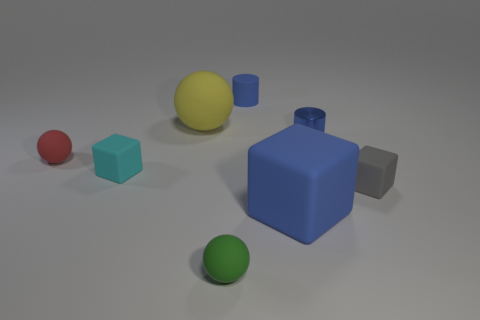What is the big yellow ball made of?
Keep it short and to the point. Rubber. What size is the matte object that is right of the blue matte cylinder and in front of the small gray thing?
Your response must be concise. Large. There is a large block that is the same color as the shiny cylinder; what is it made of?
Provide a succinct answer. Rubber. How many small blue shiny cylinders are there?
Ensure brevity in your answer.  1. Is the number of large blue objects less than the number of brown matte balls?
Your response must be concise. No. What is the material of the blue thing that is the same size as the blue matte cylinder?
Make the answer very short. Metal. How many objects are cyan objects or big brown rubber spheres?
Your answer should be very brief. 1. What number of things are behind the small green sphere and in front of the tiny gray cube?
Provide a short and direct response. 1. Is the number of green objects that are on the left side of the tiny green rubber ball less than the number of gray objects?
Make the answer very short. Yes. What shape is the thing that is the same size as the yellow sphere?
Your answer should be compact. Cube. 